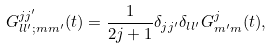Convert formula to latex. <formula><loc_0><loc_0><loc_500><loc_500>G _ { l l ^ { \prime } ; m m ^ { \prime } } ^ { j j ^ { \prime } } ( t ) = \frac { 1 } { 2 j + 1 } \delta _ { j j ^ { \prime } } \delta _ { l l ^ { \prime } } G _ { m ^ { \prime } m } ^ { j } ( t ) ,</formula> 